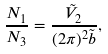<formula> <loc_0><loc_0><loc_500><loc_500>\frac { N _ { 1 } } { N _ { 3 } } = \frac { \tilde { V } _ { 2 } } { ( 2 \pi ) ^ { 2 } \tilde { b } } ,</formula> 